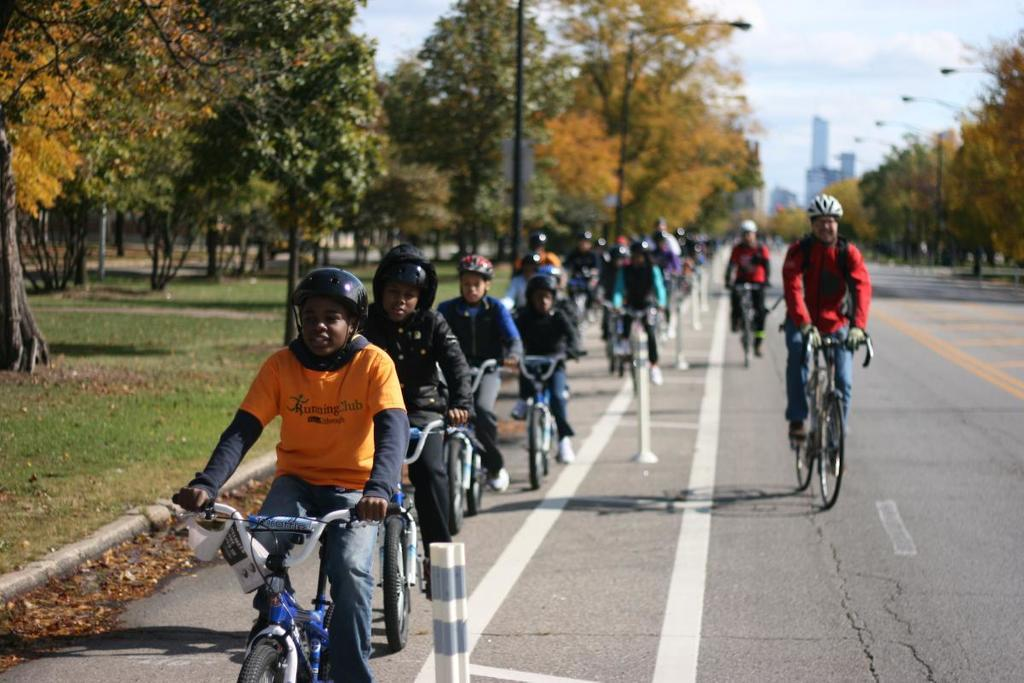What are the people in the image doing? People are riding bicycles on the road in the image. What safety precaution are the people taking while riding their bicycles? The people are wearing helmets. What can be seen on both sides of the road? There are trees to the left and right of the road. What can be seen in the distance behind the people? There are buildings visible in the background. What is the position of the voice in the image? There is no voice present in the image. 